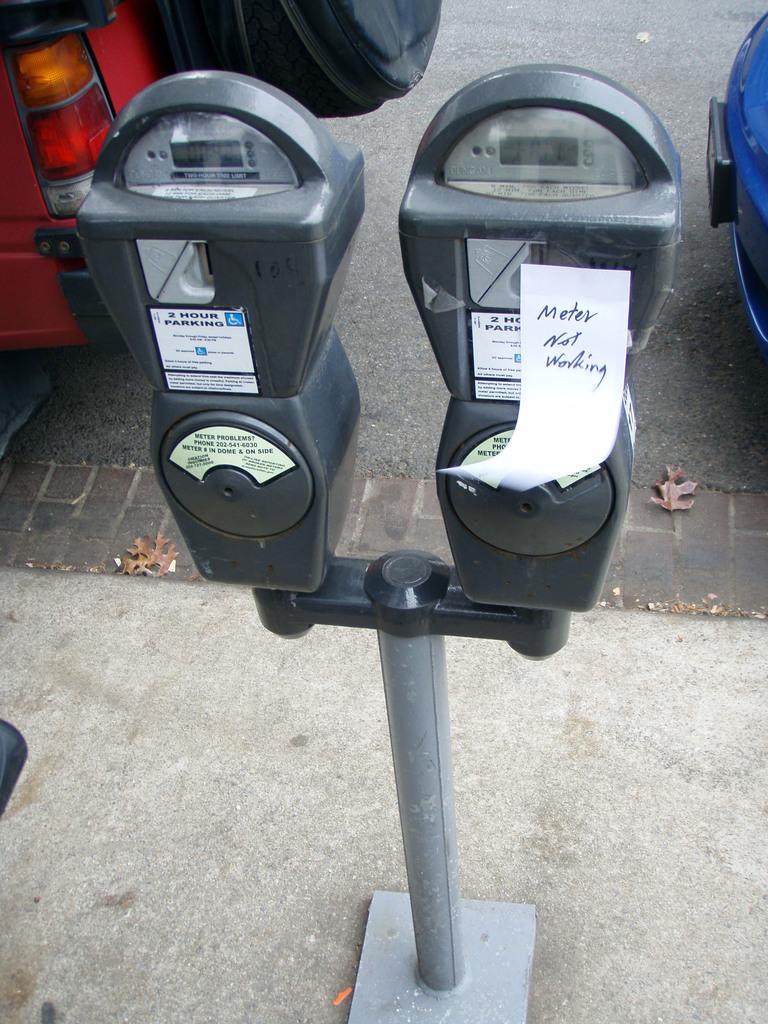What is not working?
Make the answer very short. Meter. Should we use the meter on the left or right?
Provide a short and direct response. Left. 